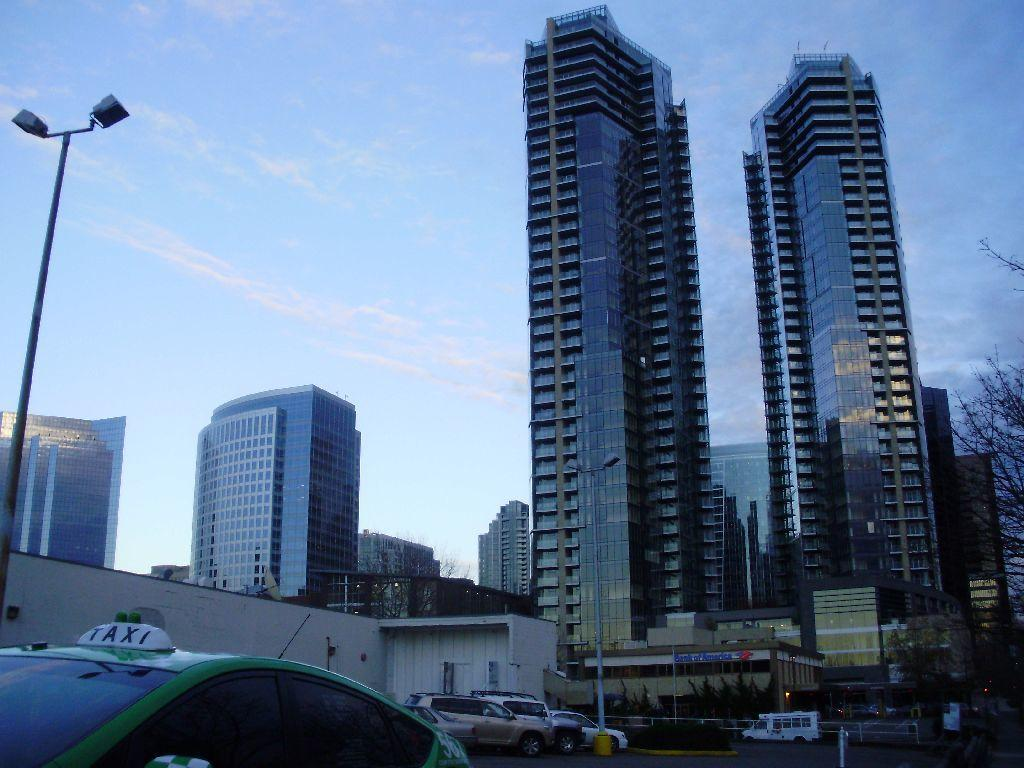What type of structures can be seen in the image? There are buildings in the image. What kind of light source is present in the image? There is a pole light in the image. How would you describe the sky in the image? The sky is blue and cloudy in the image. What is happening with the vehicles in the image? Vehicles are moving in the image. What type of natural vegetation is visible in the image? There are trees in the image. Can you see a bottle of friction on the tramp in the image? There is no bottle of friction or tramp present in the image. 